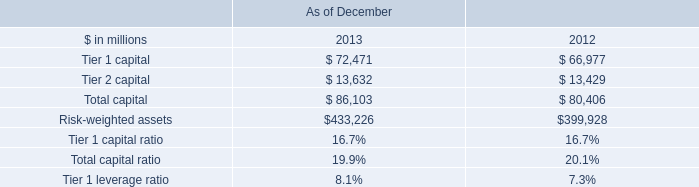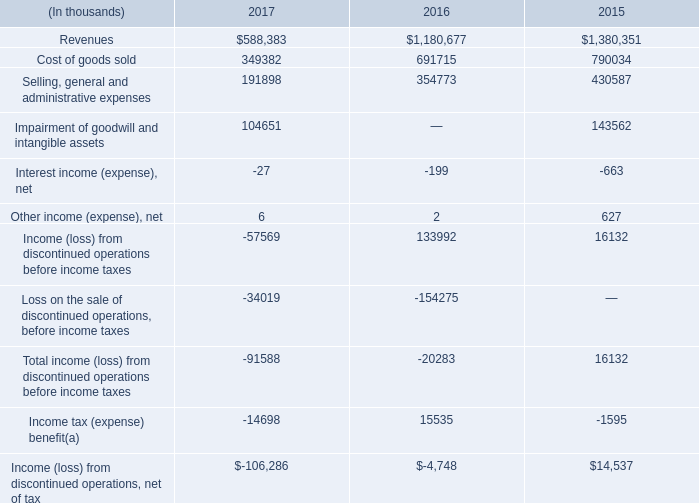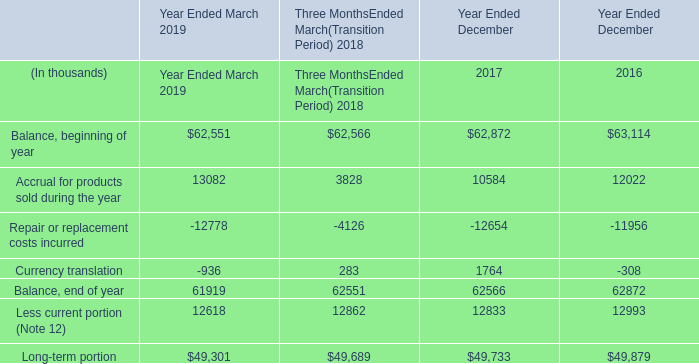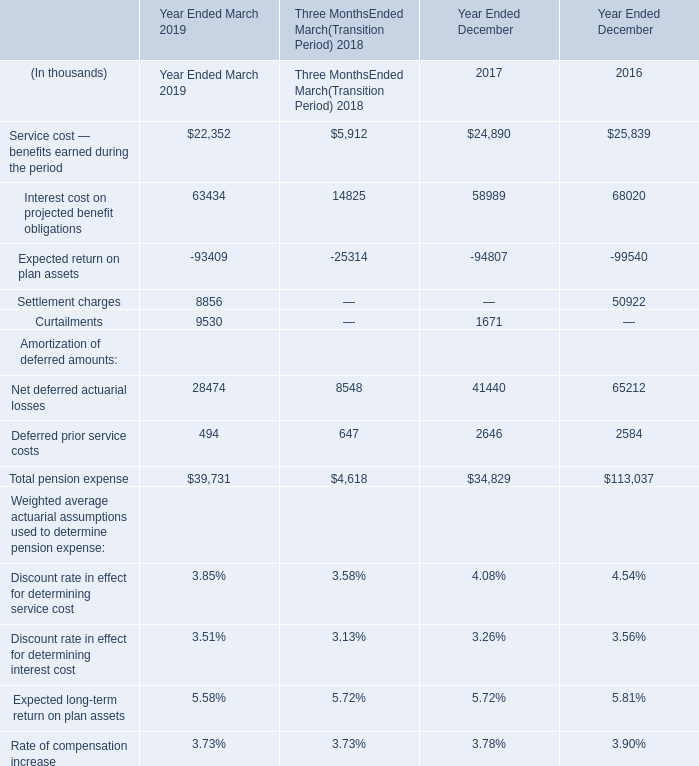What's the sum of all pension expense that are greater than 20000 in Year Ended March 2019? (in thousand) 
Computations: ((22352 + 63434) + 28474)
Answer: 114260.0. 